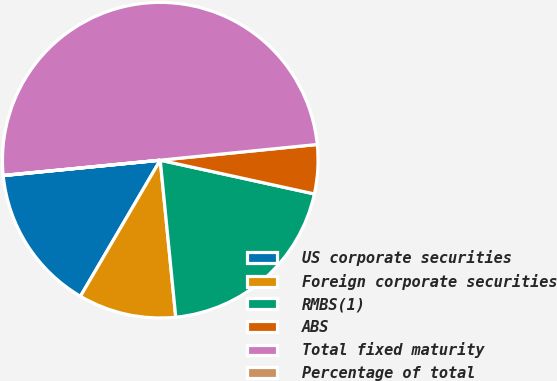Convert chart. <chart><loc_0><loc_0><loc_500><loc_500><pie_chart><fcel>US corporate securities<fcel>Foreign corporate securities<fcel>RMBS(1)<fcel>ABS<fcel>Total fixed maturity<fcel>Percentage of total<nl><fcel>15.0%<fcel>10.01%<fcel>20.0%<fcel>5.02%<fcel>49.96%<fcel>0.02%<nl></chart> 